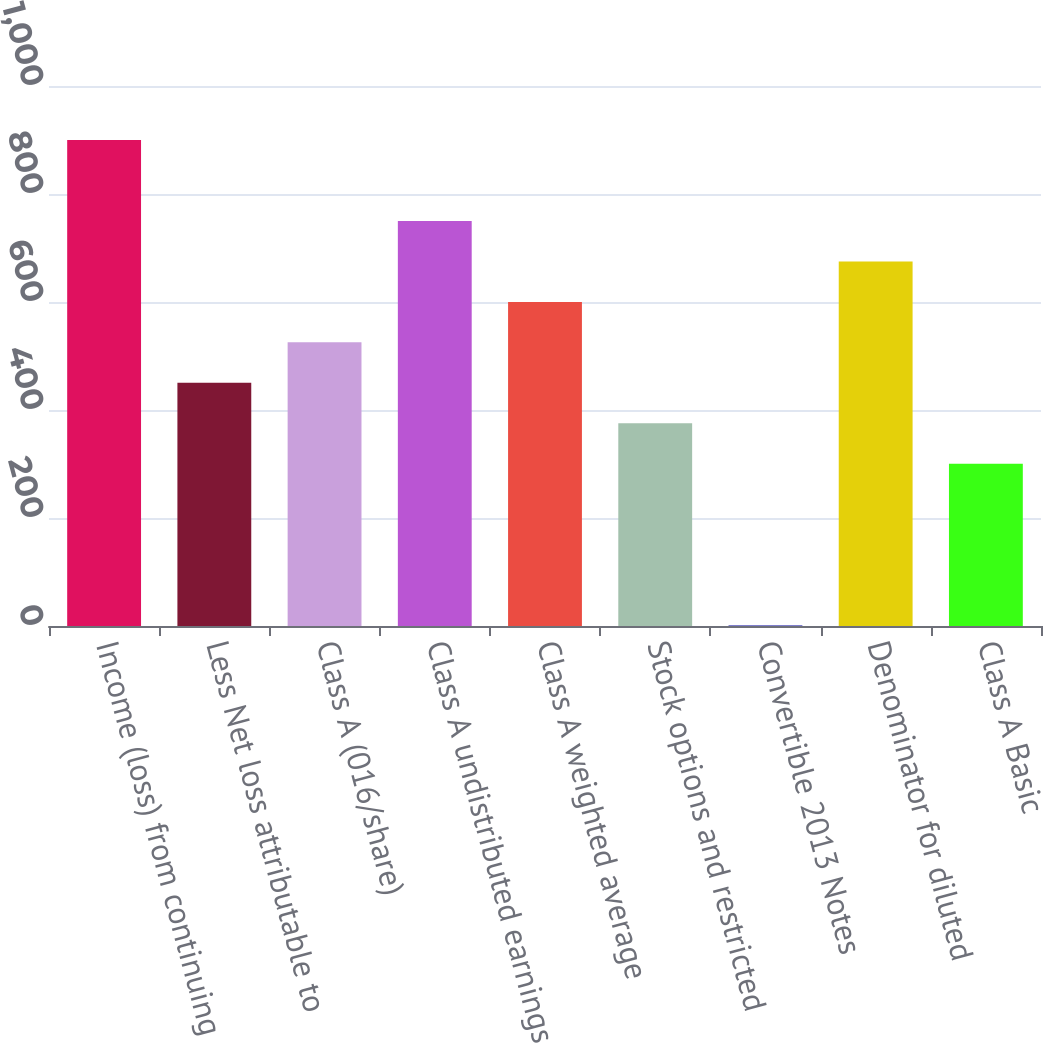Convert chart to OTSL. <chart><loc_0><loc_0><loc_500><loc_500><bar_chart><fcel>Income (loss) from continuing<fcel>Less Net loss attributable to<fcel>Class A (016/share)<fcel>Class A undistributed earnings<fcel>Class A weighted average<fcel>Stock options and restricted<fcel>Convertible 2013 Notes<fcel>Denominator for diluted<fcel>Class A Basic<nl><fcel>899.8<fcel>450.4<fcel>525.3<fcel>750<fcel>600.2<fcel>375.5<fcel>1<fcel>675.1<fcel>300.6<nl></chart> 